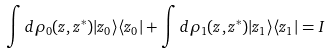<formula> <loc_0><loc_0><loc_500><loc_500>\int d \rho _ { 0 } ( z , z ^ { * } ) | z _ { 0 } \rangle \langle z _ { 0 } | + \int d \rho _ { 1 } ( z , z ^ { * } ) | z _ { 1 } \rangle \langle z _ { 1 } | = I</formula> 